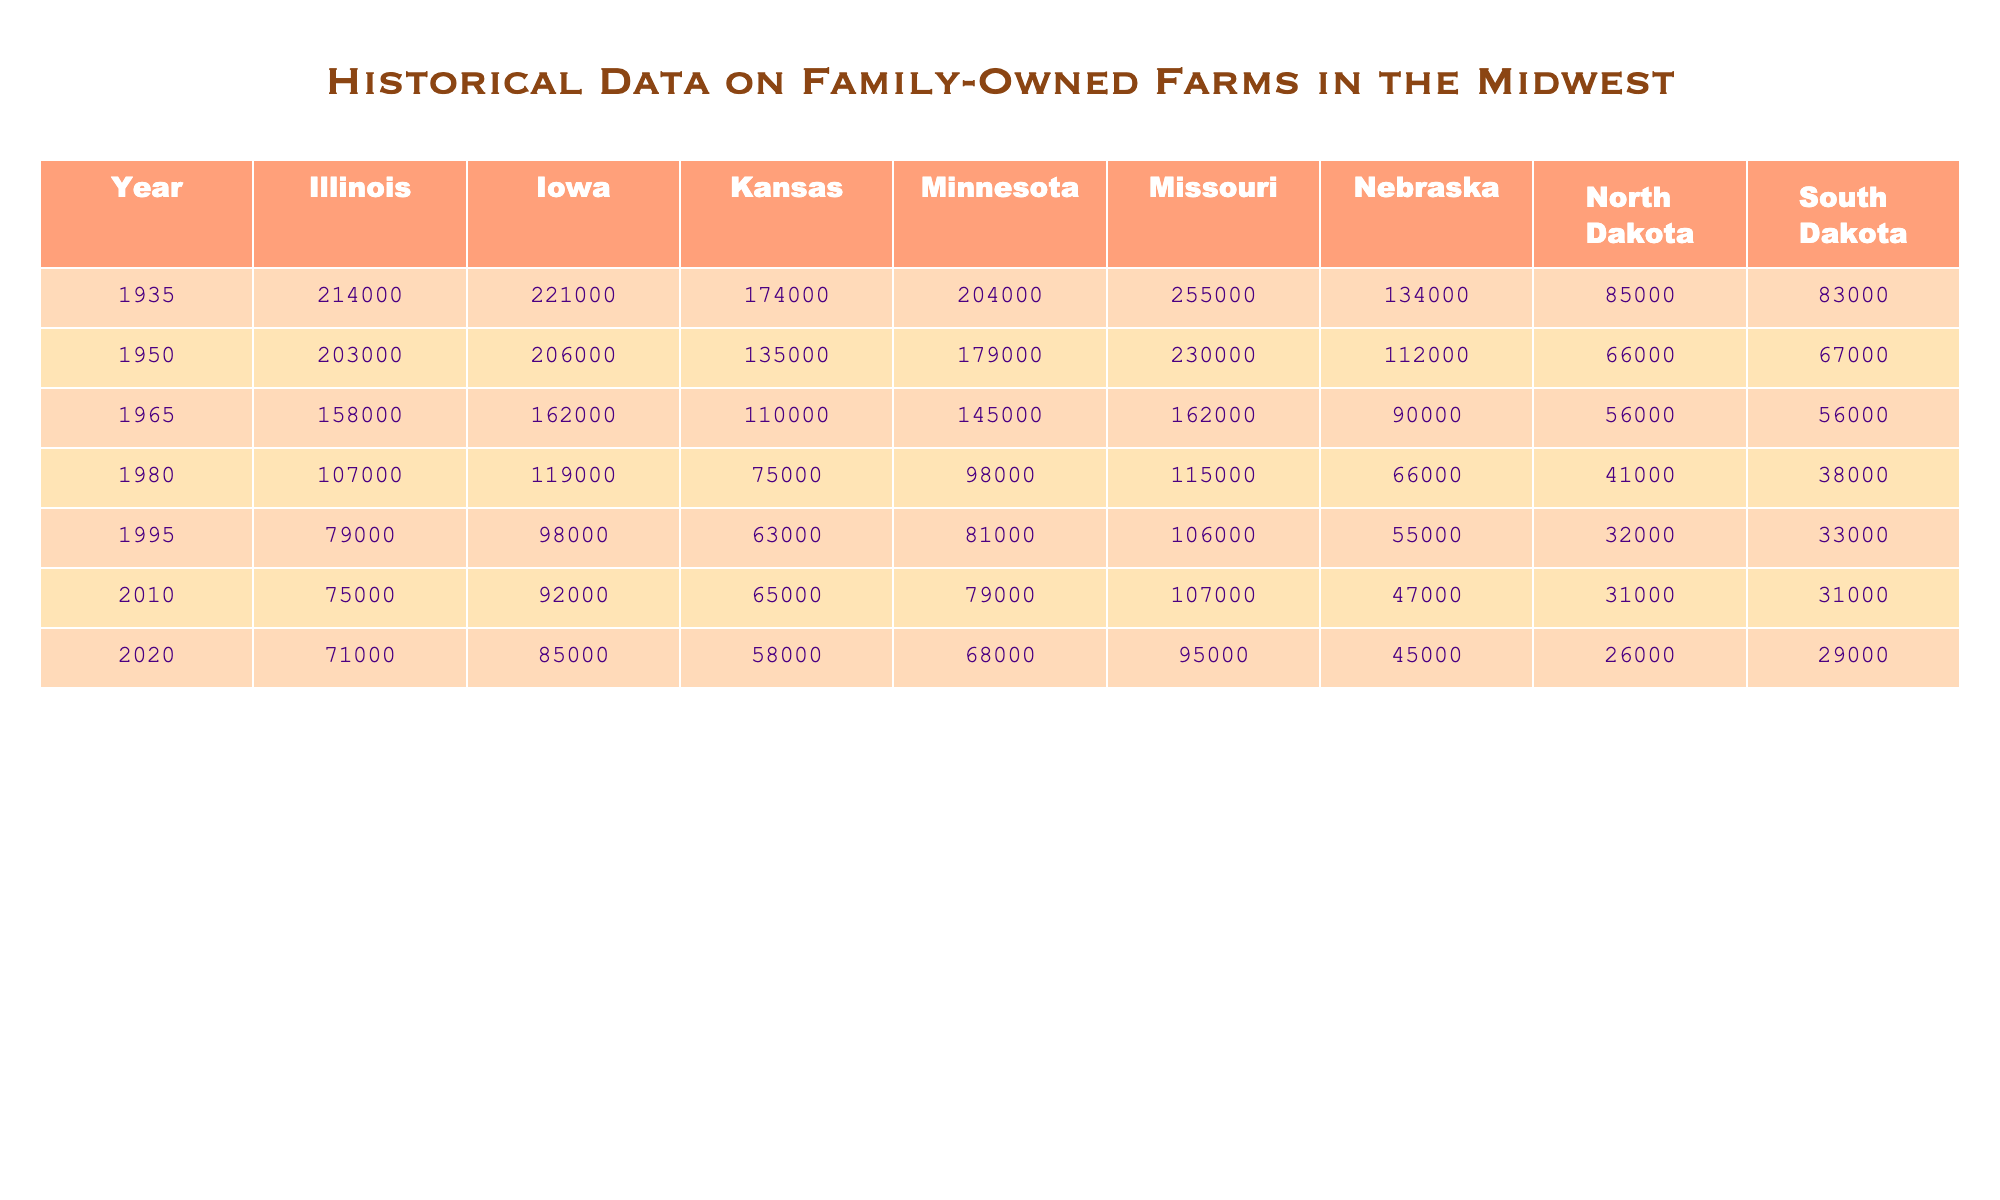What was the number of family-owned farms in Illinois in 1950? In the year 1950, the table shows that Illinois had 203,000 family-owned farms.
Answer: 203000 Which state had the highest number of family-owned farms in 1935? According to the table, Missouri had the highest number of family-owned farms in 1935 with 255,000.
Answer: Missouri What is the difference in the number of family-owned farms in Iowa between 1980 and 1965? In 1980, Iowa had 119,000 farms and in 1965 it had 162,000. The difference is 162,000 - 119,000 = 43,000.
Answer: 43000 What was the average number of family-owned farms across all states in 2010? To find the average for 2010, we sum the values: 75,000 (Illinois) + 92,000 (Iowa) + 65,000 (Kansas) + 79,000 (Minnesota) + 107,000 (Missouri) + 47,000 (Nebraska) + 31,000 (North Dakota) + 31,000 (South Dakota) = 487,000. Dividing by the number of states (8), the average is 487,000 / 8 = 60,875.
Answer: 60875 Did the number of family-owned farms in South Dakota increase, decrease, or stay the same from 1950 to 2020? In 1950, South Dakota had 67,000 farms and in 2020 it had 29,000 farms. This shows a decrease in the number of family-owned farms in South Dakota.
Answer: Decrease Which year saw the largest decline in family-owned farms for Kansas compared to the previous year? The largest decline for Kansas was from 1950 to 1965 where it dropped from 135,000 to 110,000, a difference of 25,000.
Answer: 1965 How many family-owned farms were there in total across all states in 1980? Summing the family-owned farms for each state in 1980 gives: 107,000 + 119,000 + 75,000 + 98,000 + 115,000 + 66,000 + 41,000 + 38,000 = 619,000.
Answer: 619000 In which year did Nebraska have the fewest family-owned farms? The fewest number of family-owned farms in Nebraska was in 2020 with 45,000 farms.
Answer: 2020 What trend can be observed in the total number of family-owned farms in the Midwest from 1935 to 2020? An overall decline in the total number of family-owned farms is observed from 1935 through to 2020, indicating a consistent decrease over the decades.
Answer: Decline 